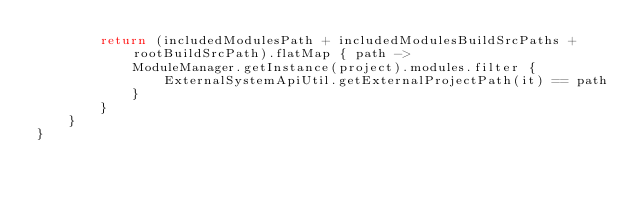Convert code to text. <code><loc_0><loc_0><loc_500><loc_500><_Kotlin_>        return (includedModulesPath + includedModulesBuildSrcPaths + rootBuildSrcPath).flatMap { path ->
            ModuleManager.getInstance(project).modules.filter {
                ExternalSystemApiUtil.getExternalProjectPath(it) == path
            }
        }
    }
}</code> 